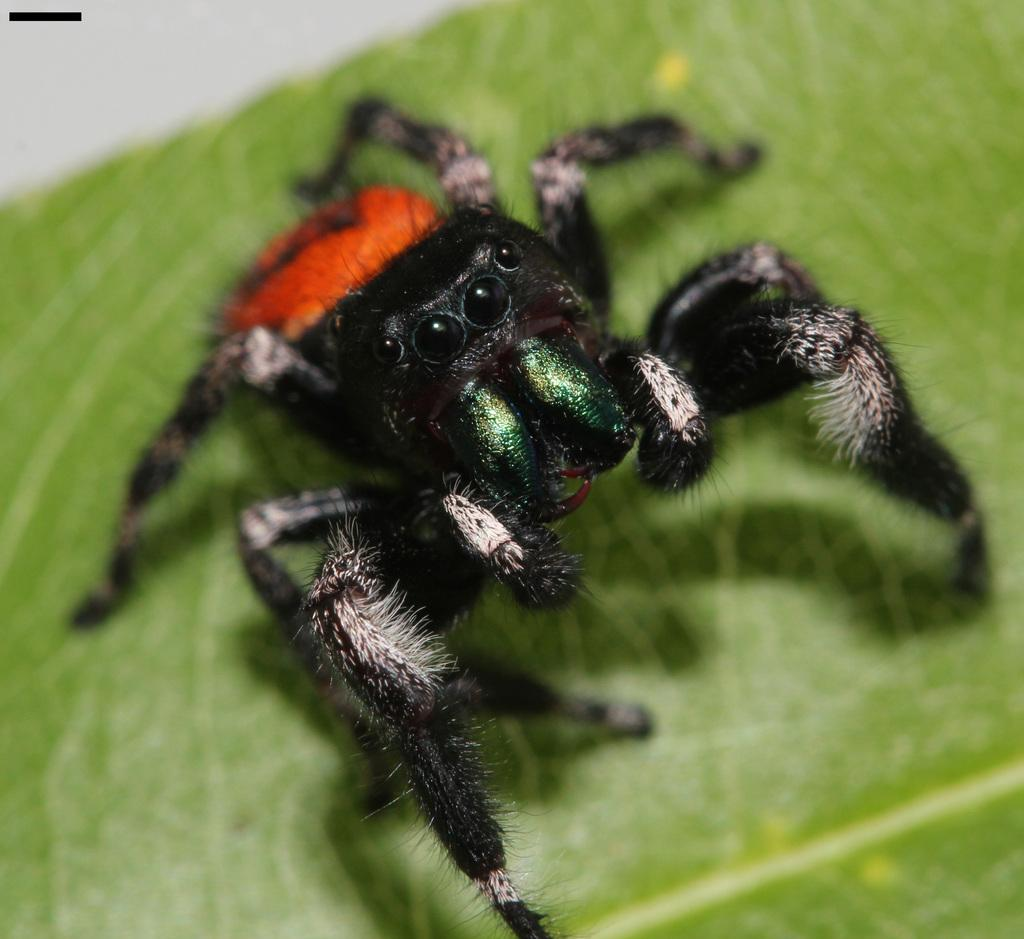What is the main subject of the image? The main subject of the image is a spider. Where is the spider located in the image? The spider is on a leaf in the image. What can be observed about the positioning of the spider and leaf in the image? The spider and leaf are in the center of the image. What type of comb does the spider use to groom itself in the image? There is no comb present in the image, and spiders do not use combs to groom themselves. 